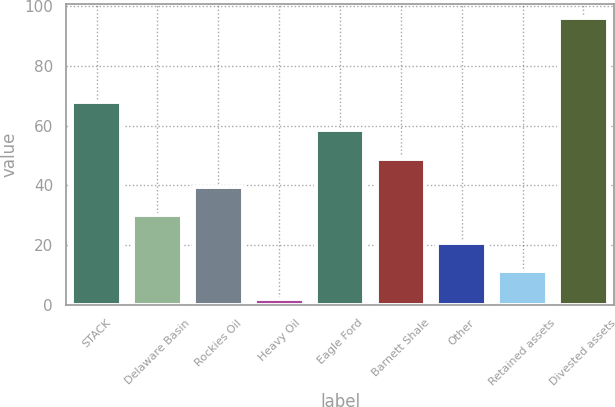Convert chart. <chart><loc_0><loc_0><loc_500><loc_500><bar_chart><fcel>STACK<fcel>Delaware Basin<fcel>Rockies Oil<fcel>Heavy Oil<fcel>Eagle Ford<fcel>Barnett Shale<fcel>Other<fcel>Retained assets<fcel>Divested assets<nl><fcel>67.8<fcel>30.2<fcel>39.6<fcel>2<fcel>58.4<fcel>49<fcel>20.8<fcel>11.4<fcel>96<nl></chart> 